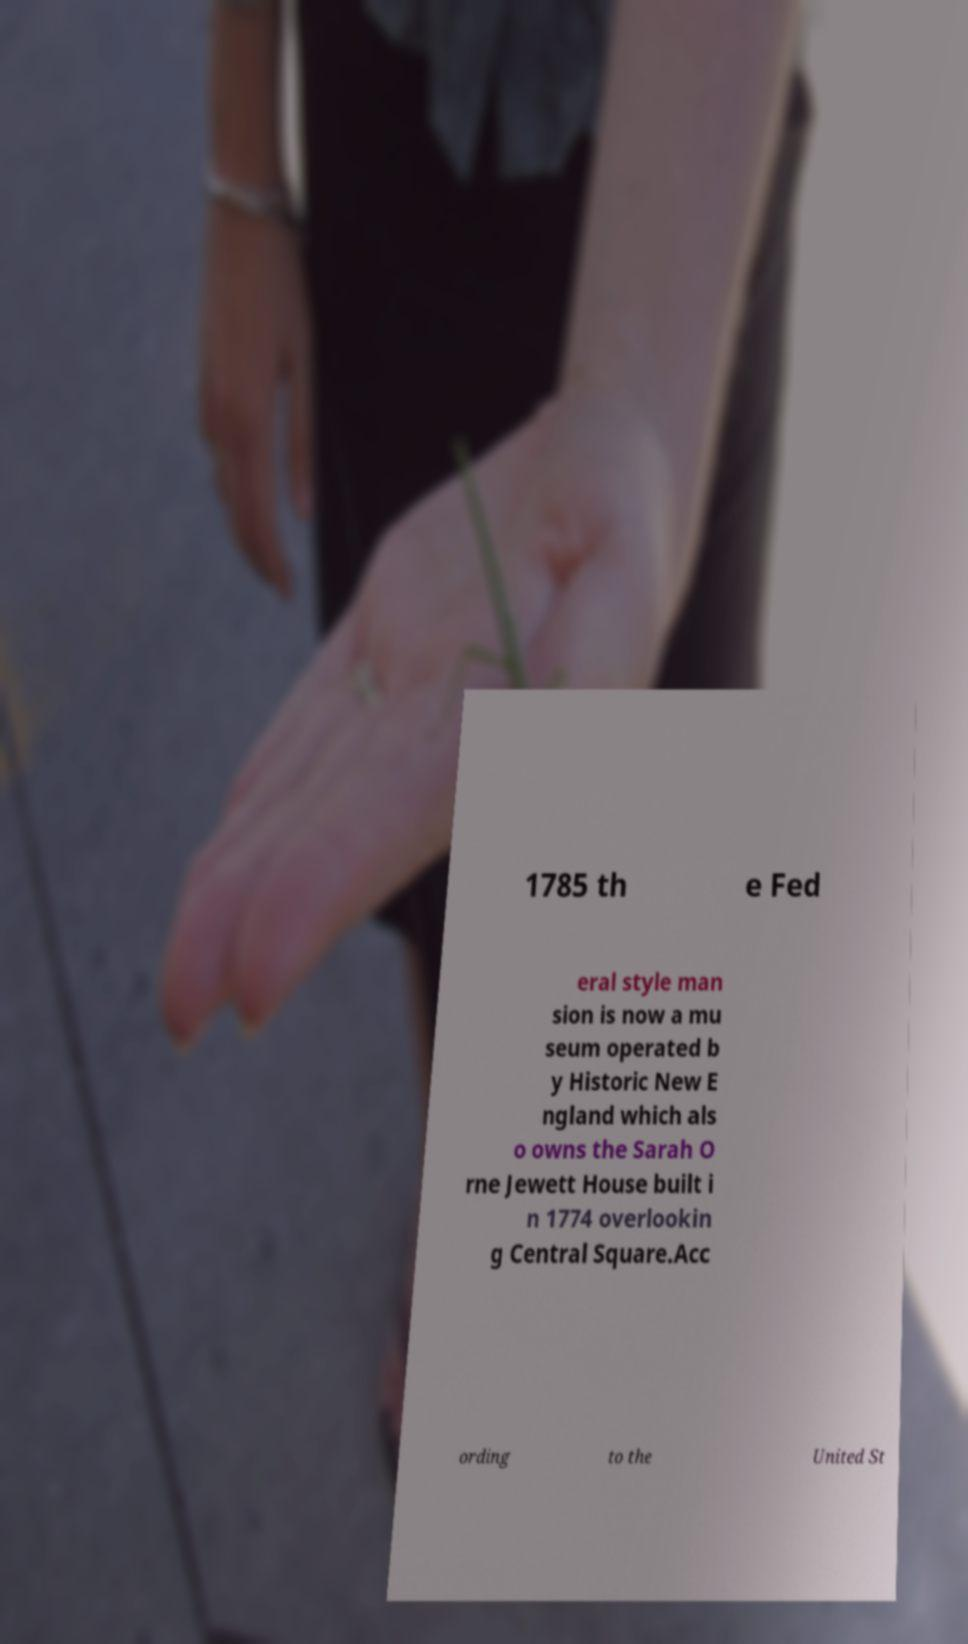Could you extract and type out the text from this image? 1785 th e Fed eral style man sion is now a mu seum operated b y Historic New E ngland which als o owns the Sarah O rne Jewett House built i n 1774 overlookin g Central Square.Acc ording to the United St 